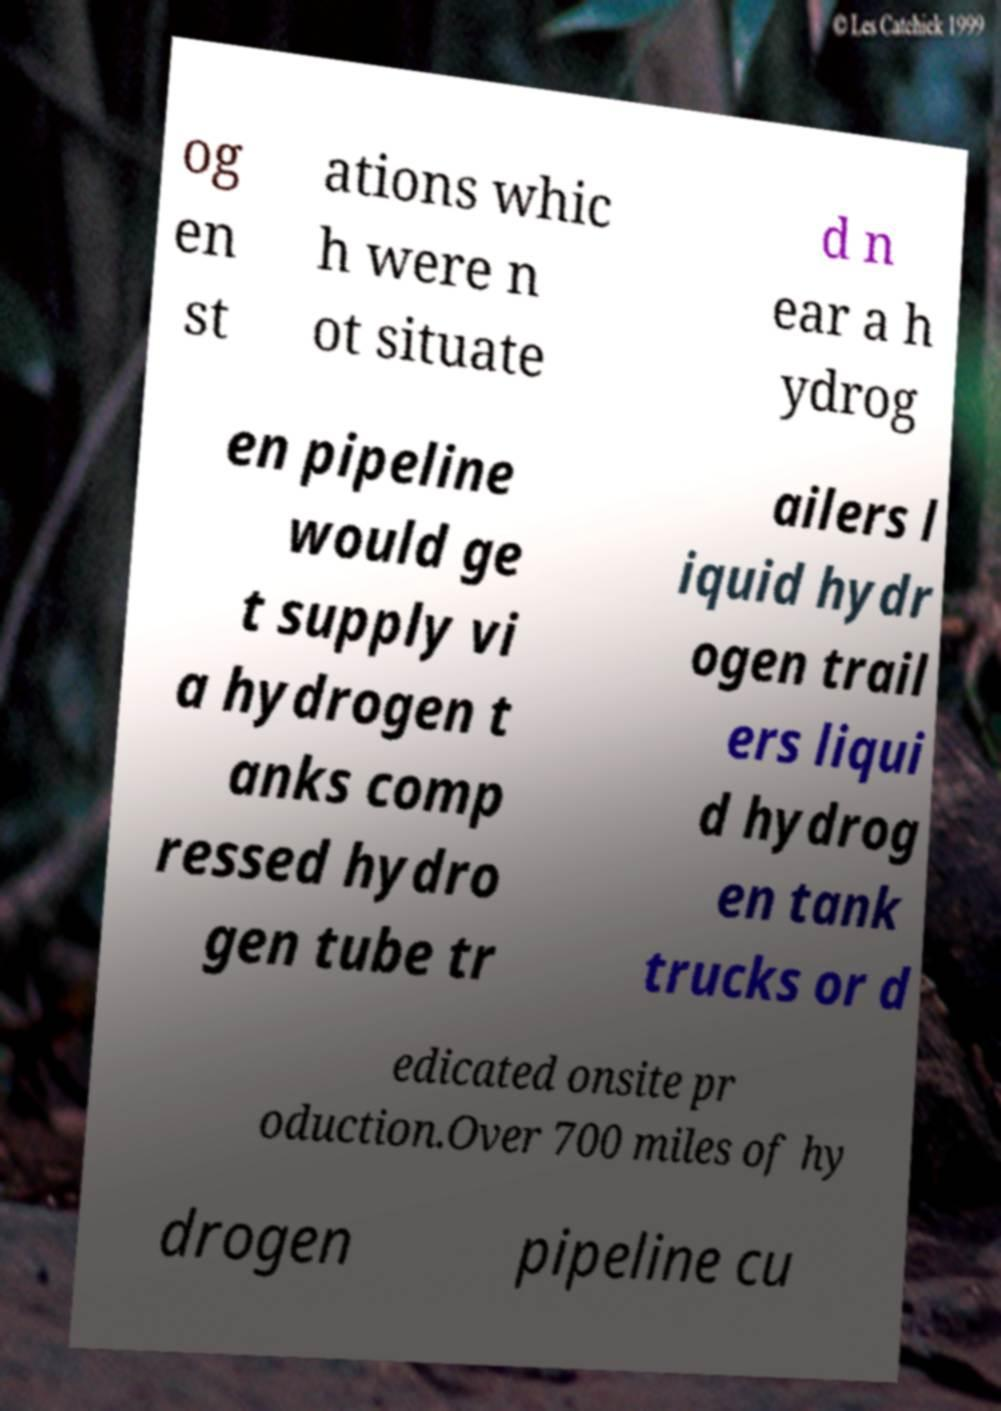Can you accurately transcribe the text from the provided image for me? og en st ations whic h were n ot situate d n ear a h ydrog en pipeline would ge t supply vi a hydrogen t anks comp ressed hydro gen tube tr ailers l iquid hydr ogen trail ers liqui d hydrog en tank trucks or d edicated onsite pr oduction.Over 700 miles of hy drogen pipeline cu 